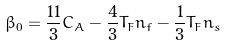<formula> <loc_0><loc_0><loc_500><loc_500>\beta _ { 0 } = \frac { 1 1 } { 3 } C _ { A } - \frac { 4 } { 3 } T _ { F } n _ { f } - \frac { 1 } { 3 } T _ { F } n _ { s }</formula> 